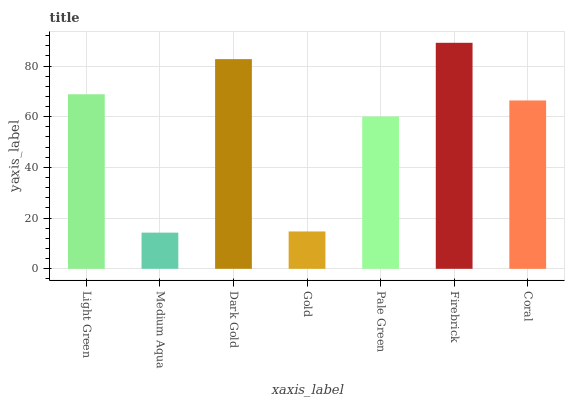Is Medium Aqua the minimum?
Answer yes or no. Yes. Is Firebrick the maximum?
Answer yes or no. Yes. Is Dark Gold the minimum?
Answer yes or no. No. Is Dark Gold the maximum?
Answer yes or no. No. Is Dark Gold greater than Medium Aqua?
Answer yes or no. Yes. Is Medium Aqua less than Dark Gold?
Answer yes or no. Yes. Is Medium Aqua greater than Dark Gold?
Answer yes or no. No. Is Dark Gold less than Medium Aqua?
Answer yes or no. No. Is Coral the high median?
Answer yes or no. Yes. Is Coral the low median?
Answer yes or no. Yes. Is Dark Gold the high median?
Answer yes or no. No. Is Gold the low median?
Answer yes or no. No. 